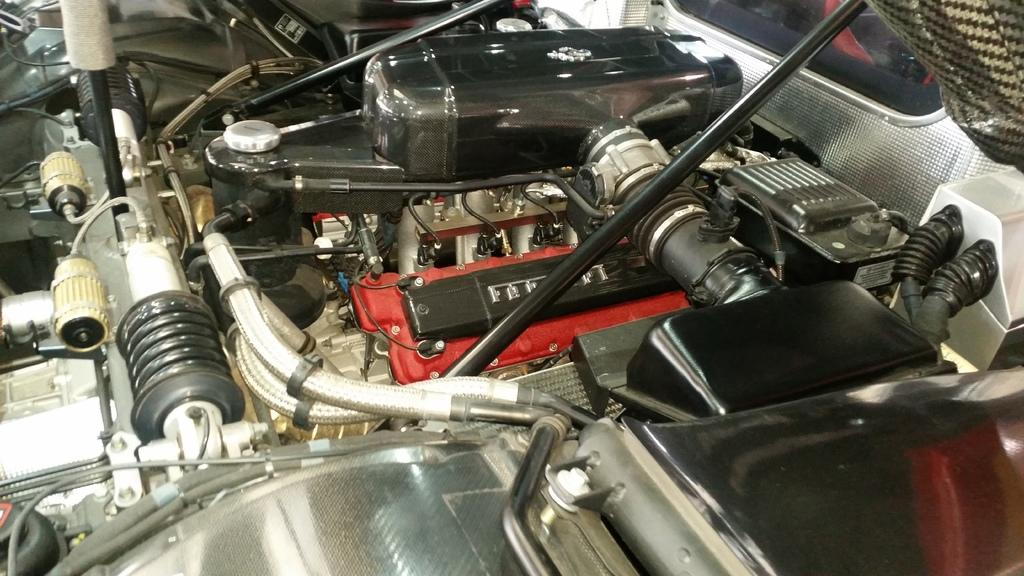What is the main subject of the image? The main subject of the image is an engine. Are there any other vehicle components visible in the image? Yes, there are other parts of a vehicle in the image. What type of flower is growing on the engine in the image? There are no flowers present in the image; it features an engine and other vehicle parts. How many wings can be seen on the engine in the image? There are no wings present on the engine in the image. 